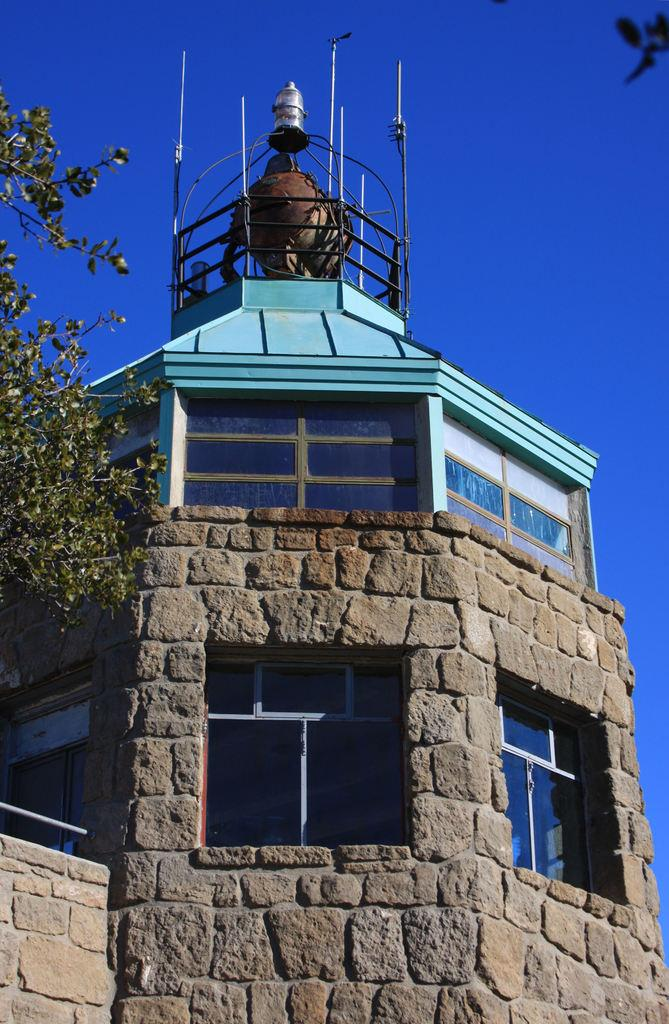What is the main structure in the front of the image? There is a building in the front of the image. What can be seen on the left side of the image? There is a tree on the left side of the image. What is located above the building? There is an antenna above the building. What is visible above the antenna? The sky is visible above the antenna. How many grapes are hanging from the tree in the image? There are no grapes visible in the image; the tree is not described as having any fruit. What type of record is being played in the image? There is no record player or music playing in the image. 